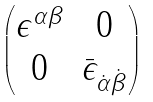Convert formula to latex. <formula><loc_0><loc_0><loc_500><loc_500>\begin{pmatrix} \epsilon ^ { \alpha \beta } & 0 \\ 0 & \bar { \epsilon } _ { \dot { \alpha } \dot { \beta } } \end{pmatrix}</formula> 